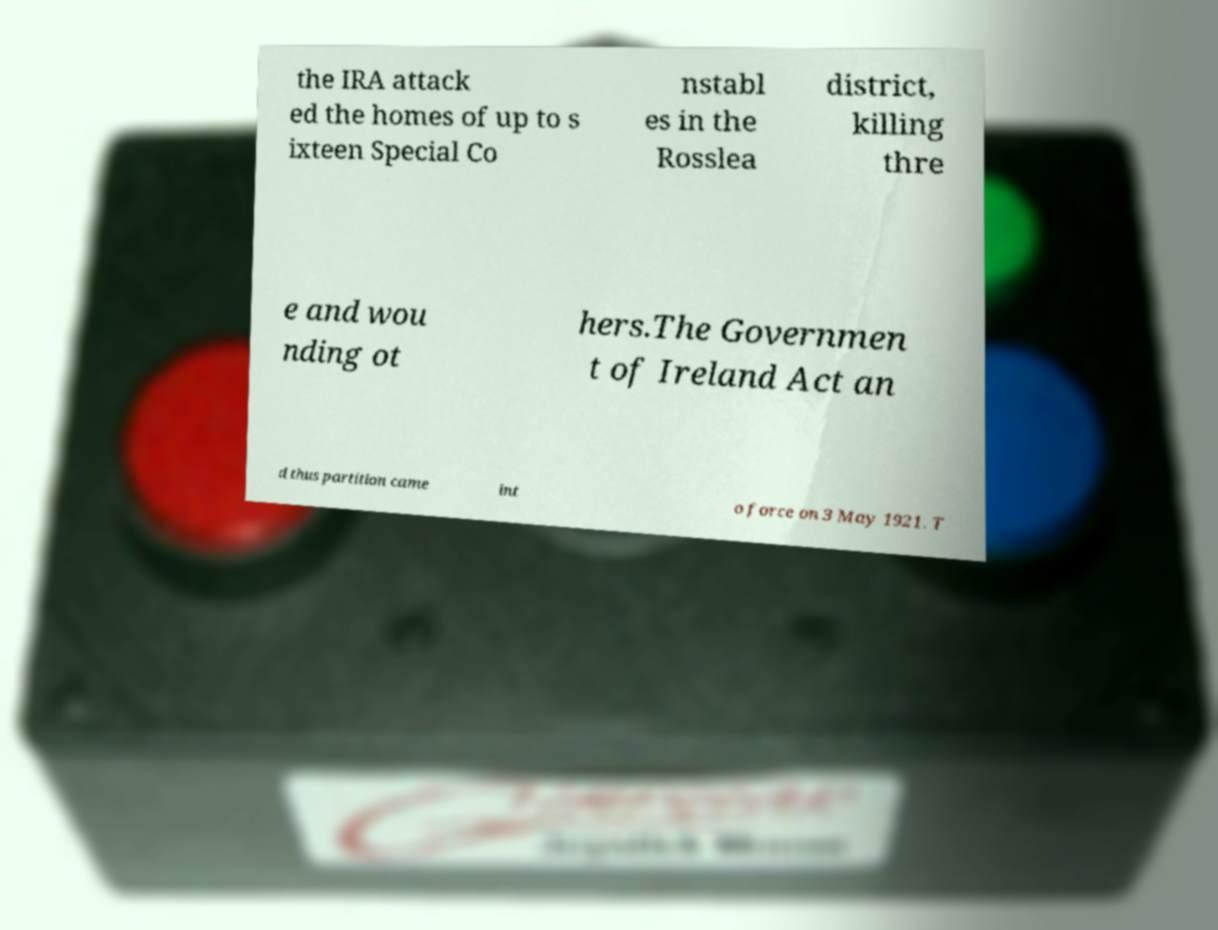Can you read and provide the text displayed in the image?This photo seems to have some interesting text. Can you extract and type it out for me? the IRA attack ed the homes of up to s ixteen Special Co nstabl es in the Rosslea district, killing thre e and wou nding ot hers.The Governmen t of Ireland Act an d thus partition came int o force on 3 May 1921. T 